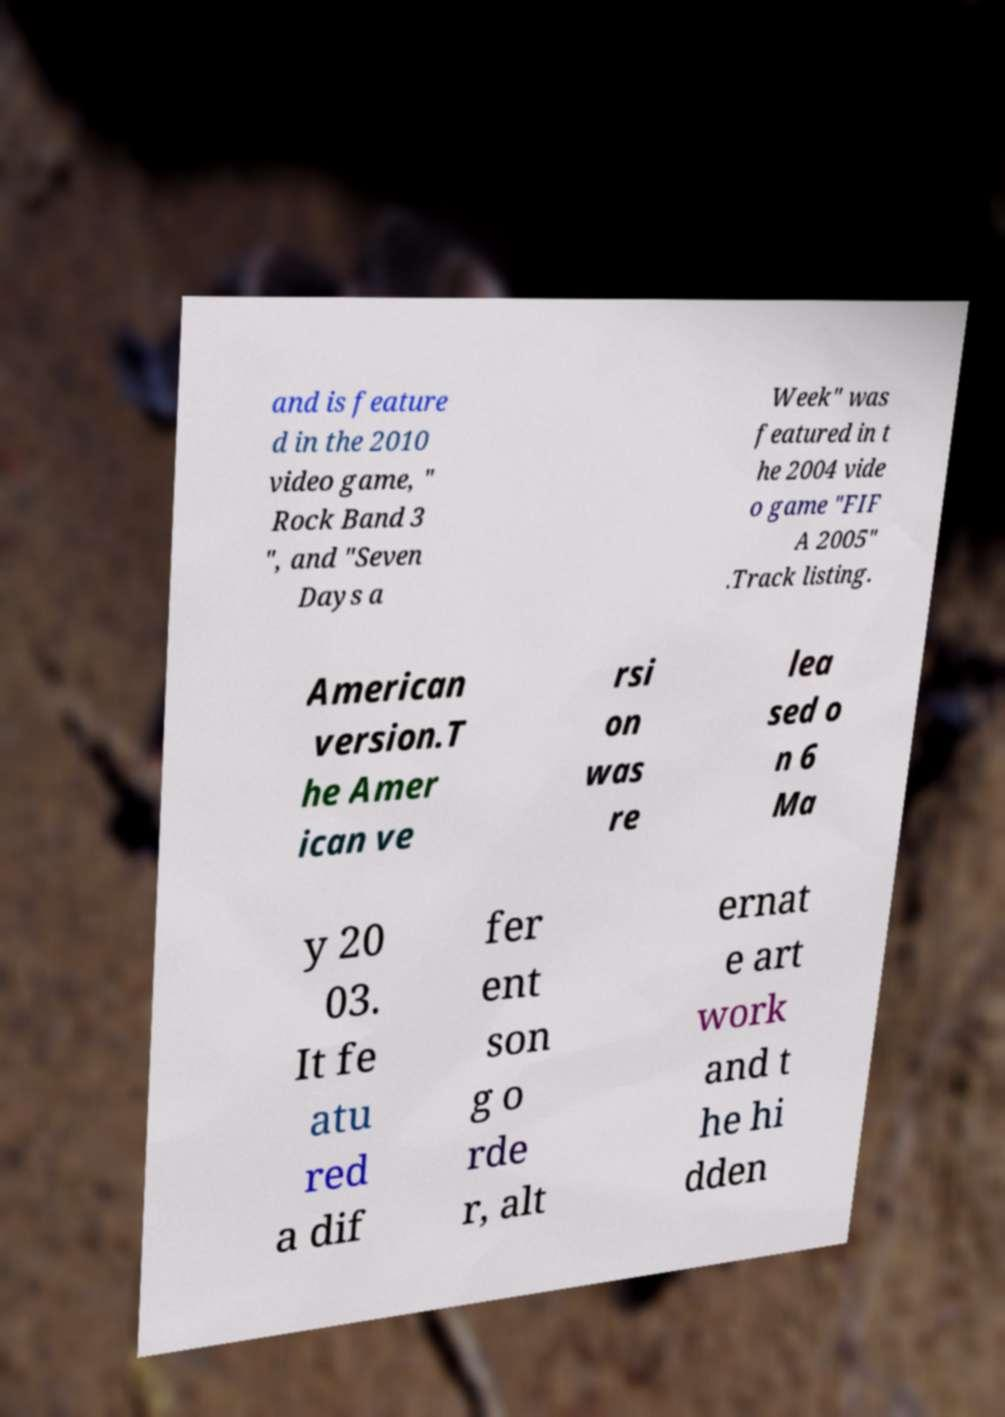Please read and relay the text visible in this image. What does it say? and is feature d in the 2010 video game, " Rock Band 3 ", and "Seven Days a Week" was featured in t he 2004 vide o game "FIF A 2005" .Track listing. American version.T he Amer ican ve rsi on was re lea sed o n 6 Ma y 20 03. It fe atu red a dif fer ent son g o rde r, alt ernat e art work and t he hi dden 